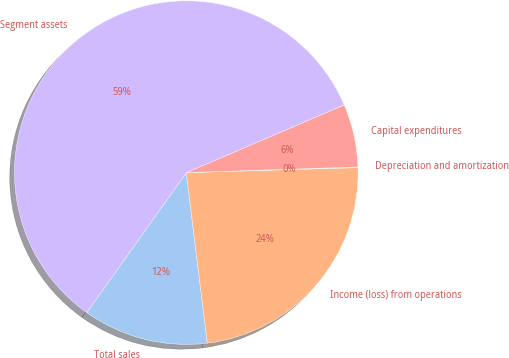<chart> <loc_0><loc_0><loc_500><loc_500><pie_chart><fcel>Total sales<fcel>Income (loss) from operations<fcel>Depreciation and amortization<fcel>Capital expenditures<fcel>Segment assets<nl><fcel>11.79%<fcel>23.52%<fcel>0.06%<fcel>5.93%<fcel>58.71%<nl></chart> 